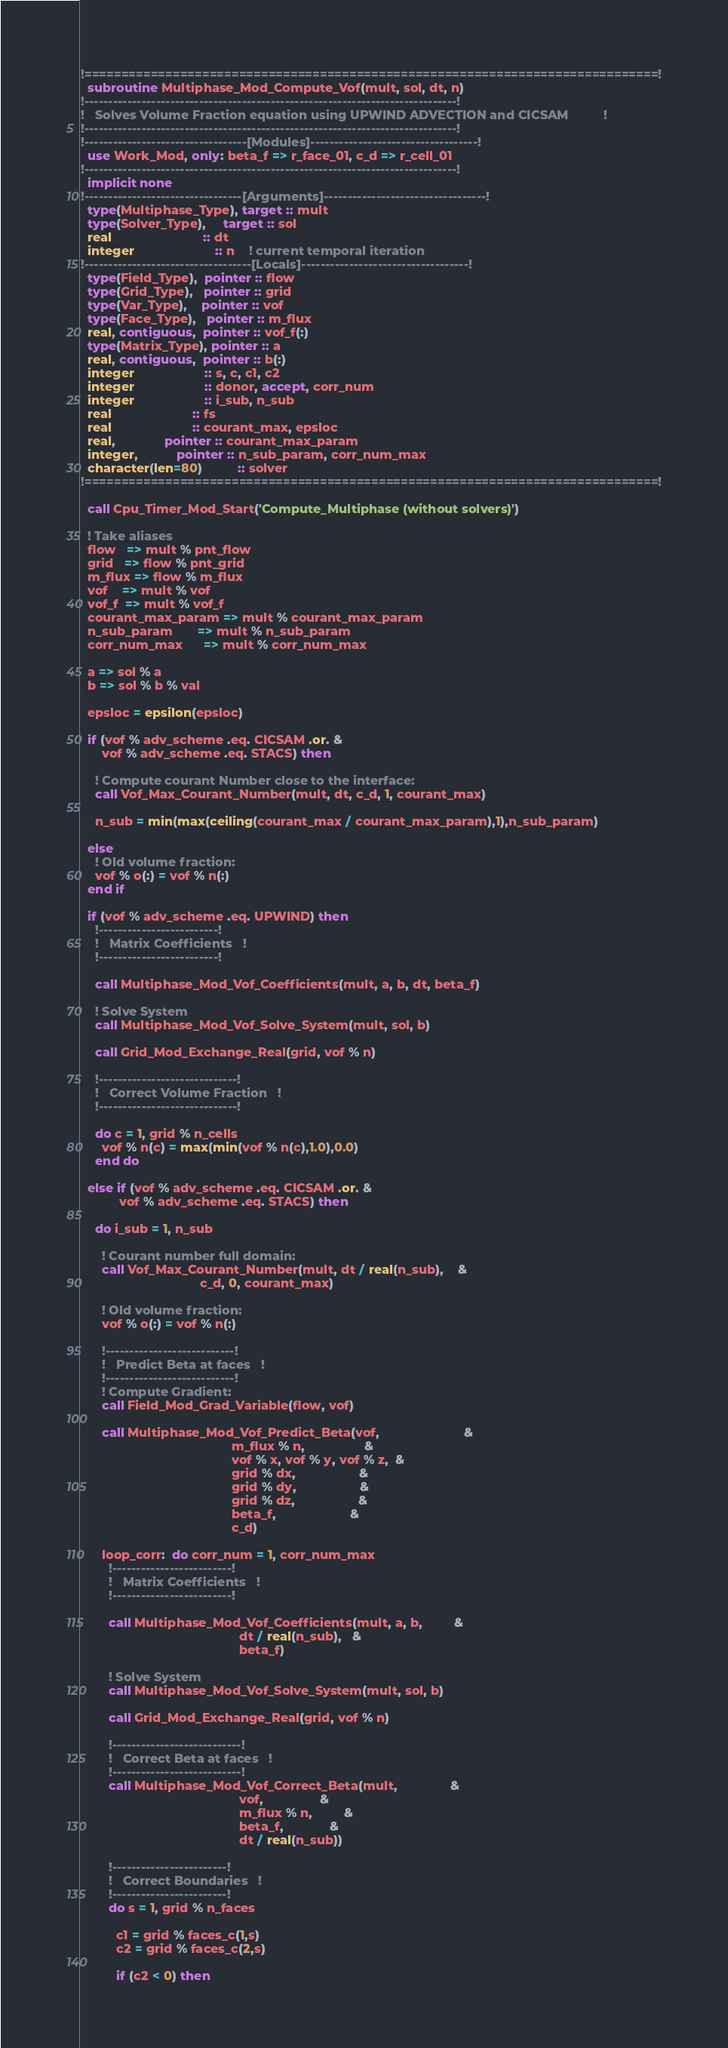Convert code to text. <code><loc_0><loc_0><loc_500><loc_500><_FORTRAN_>!==============================================================================!
  subroutine Multiphase_Mod_Compute_Vof(mult, sol, dt, n)
!------------------------------------------------------------------------------!
!   Solves Volume Fraction equation using UPWIND ADVECTION and CICSAM          !
!------------------------------------------------------------------------------!
!----------------------------------[Modules]-----------------------------------!
  use Work_Mod, only: beta_f => r_face_01, c_d => r_cell_01
!------------------------------------------------------------------------------!
  implicit none
!---------------------------------[Arguments]----------------------------------!
  type(Multiphase_Type), target :: mult
  type(Solver_Type),     target :: sol
  real                          :: dt
  integer                       :: n    ! current temporal iteration
!-----------------------------------[Locals]-----------------------------------!
  type(Field_Type),  pointer :: flow
  type(Grid_Type),   pointer :: grid
  type(Var_Type),    pointer :: vof
  type(Face_Type),   pointer :: m_flux
  real, contiguous,  pointer :: vof_f(:)
  type(Matrix_Type), pointer :: a
  real, contiguous,  pointer :: b(:)
  integer                    :: s, c, c1, c2
  integer                    :: donor, accept, corr_num
  integer                    :: i_sub, n_sub
  real                       :: fs
  real                       :: courant_max, epsloc
  real,              pointer :: courant_max_param
  integer,           pointer :: n_sub_param, corr_num_max
  character(len=80)          :: solver
!==============================================================================!

  call Cpu_Timer_Mod_Start('Compute_Multiphase (without solvers)')

  ! Take aliases
  flow   => mult % pnt_flow
  grid   => flow % pnt_grid
  m_flux => flow % m_flux
  vof    => mult % vof
  vof_f  => mult % vof_f
  courant_max_param => mult % courant_max_param
  n_sub_param       => mult % n_sub_param
  corr_num_max      => mult % corr_num_max

  a => sol % a
  b => sol % b % val

  epsloc = epsilon(epsloc)

  if (vof % adv_scheme .eq. CICSAM .or. &
      vof % adv_scheme .eq. STACS) then

    ! Compute courant Number close to the interface:
    call Vof_Max_Courant_Number(mult, dt, c_d, 1, courant_max)

    n_sub = min(max(ceiling(courant_max / courant_max_param),1),n_sub_param)

  else
    ! Old volume fraction:
    vof % o(:) = vof % n(:)
  end if

  if (vof % adv_scheme .eq. UPWIND) then
    !-------------------------!
    !   Matrix Coefficients   !
    !-------------------------!

    call Multiphase_Mod_Vof_Coefficients(mult, a, b, dt, beta_f)

    ! Solve System
    call Multiphase_Mod_Vof_Solve_System(mult, sol, b)

    call Grid_Mod_Exchange_Real(grid, vof % n)

    !-----------------------------!
    !   Correct Volume Fraction   !
    !-----------------------------!

    do c = 1, grid % n_cells
      vof % n(c) = max(min(vof % n(c),1.0),0.0)
    end do

  else if (vof % adv_scheme .eq. CICSAM .or. &
           vof % adv_scheme .eq. STACS) then

    do i_sub = 1, n_sub

      ! Courant number full domain:
      call Vof_Max_Courant_Number(mult, dt / real(n_sub),    &
                                  c_d, 0, courant_max)

      ! Old volume fraction:
      vof % o(:) = vof % n(:)

      !---------------------------!
      !   Predict Beta at faces   !
      !---------------------------!
      ! Compute Gradient:
      call Field_Mod_Grad_Variable(flow, vof)

      call Multiphase_Mod_Vof_Predict_Beta(vof,                        &
                                           m_flux % n,                 &
                                           vof % x, vof % y, vof % z,  &
                                           grid % dx,                  &
                                           grid % dy,                  &
                                           grid % dz,                  &
                                           beta_f,                     &
                                           c_d)

      loop_corr:  do corr_num = 1, corr_num_max
        !-------------------------!
        !   Matrix Coefficients   !
        !-------------------------!

        call Multiphase_Mod_Vof_Coefficients(mult, a, b,         &
                                             dt / real(n_sub),   &
                                             beta_f)

        ! Solve System
        call Multiphase_Mod_Vof_Solve_System(mult, sol, b)

        call Grid_Mod_Exchange_Real(grid, vof % n)

        !---------------------------!
        !   Correct Beta at faces   !
        !---------------------------!
        call Multiphase_Mod_Vof_Correct_Beta(mult,               &
                                             vof,                &
                                             m_flux % n,         &
                                             beta_f,             &
                                             dt / real(n_sub))

        !------------------------!
        !   Correct Boundaries   !
        !------------------------!
        do s = 1, grid % n_faces

          c1 = grid % faces_c(1,s)
          c2 = grid % faces_c(2,s)

          if (c2 < 0) then</code> 